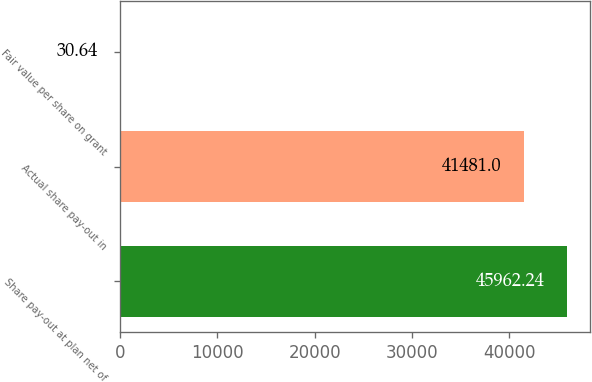<chart> <loc_0><loc_0><loc_500><loc_500><bar_chart><fcel>Share pay-out at plan net of<fcel>Actual share pay-out in<fcel>Fair value per share on grant<nl><fcel>45962.2<fcel>41481<fcel>30.64<nl></chart> 